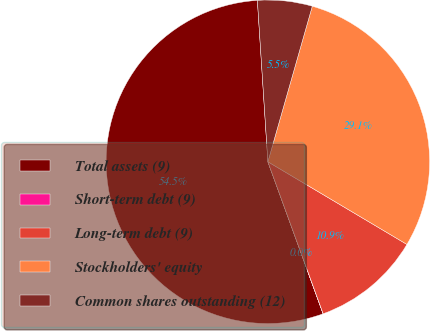Convert chart to OTSL. <chart><loc_0><loc_0><loc_500><loc_500><pie_chart><fcel>Total assets (9)<fcel>Short-term debt (9)<fcel>Long-term debt (9)<fcel>Stockholders' equity<fcel>Common shares outstanding (12)<nl><fcel>54.51%<fcel>0.01%<fcel>10.91%<fcel>29.11%<fcel>5.46%<nl></chart> 